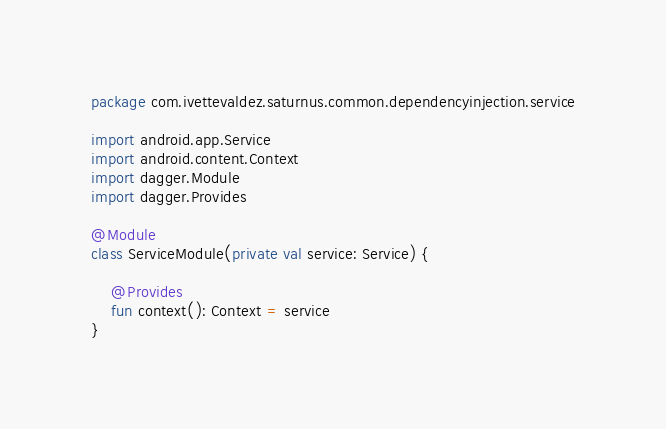<code> <loc_0><loc_0><loc_500><loc_500><_Kotlin_>package com.ivettevaldez.saturnus.common.dependencyinjection.service

import android.app.Service
import android.content.Context
import dagger.Module
import dagger.Provides

@Module
class ServiceModule(private val service: Service) {

    @Provides
    fun context(): Context = service
}</code> 